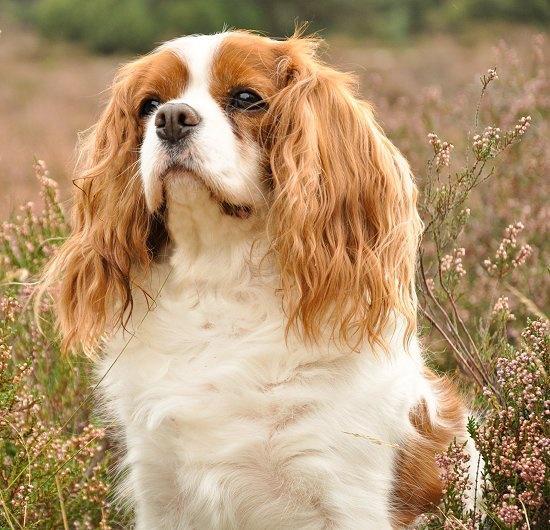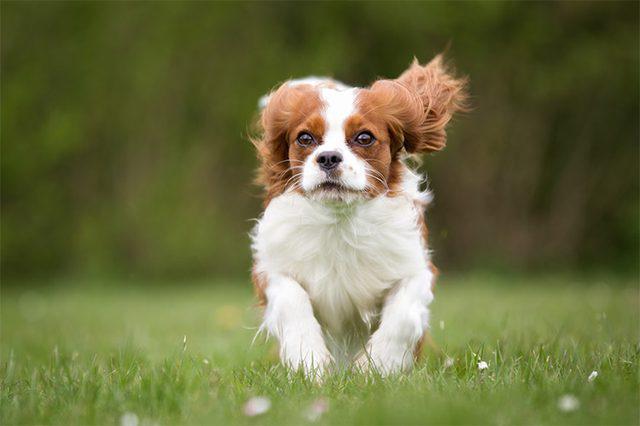The first image is the image on the left, the second image is the image on the right. Analyze the images presented: Is the assertion "You can clearly see at least one dogs leg, unobstructed by hanging fur." valid? Answer yes or no. Yes. 